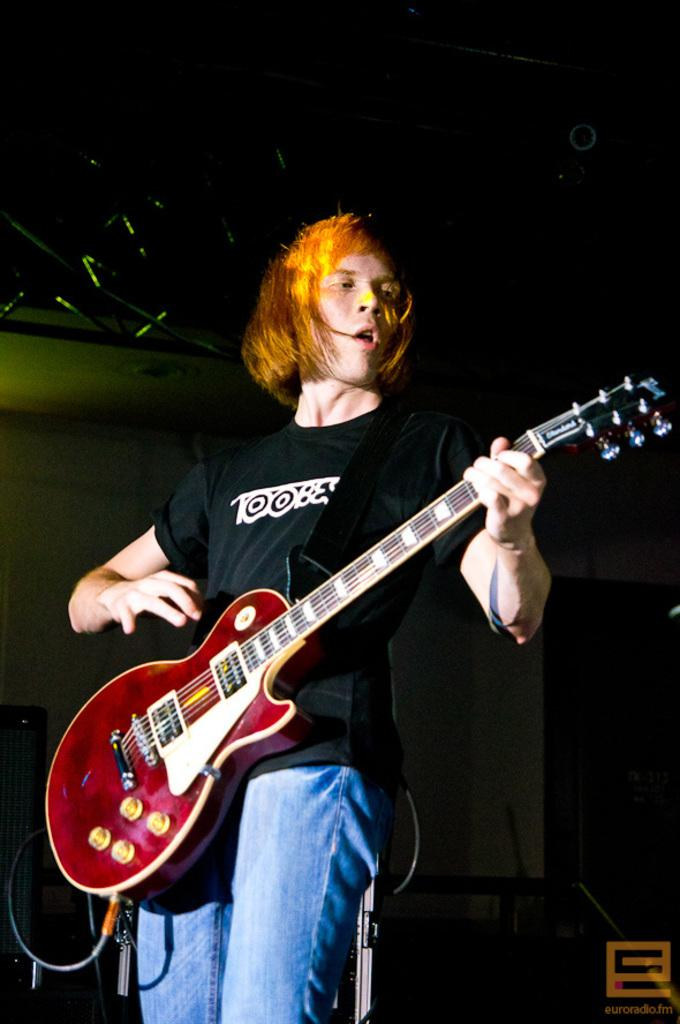What is the main subject of the image? The main subject of the image is a man. What is the man doing in the image? The man is standing and playing the guitar. What type of butter is being used to play the guitar in the image? There is no butter present in the image, and it is not being used to play the guitar. 